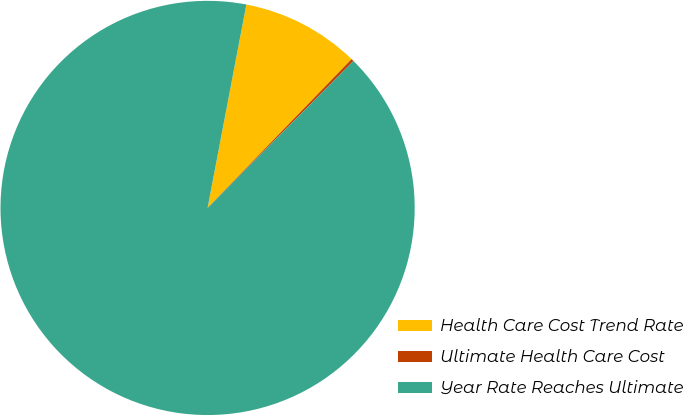<chart> <loc_0><loc_0><loc_500><loc_500><pie_chart><fcel>Health Care Cost Trend Rate<fcel>Ultimate Health Care Cost<fcel>Year Rate Reaches Ultimate<nl><fcel>9.24%<fcel>0.2%<fcel>90.56%<nl></chart> 